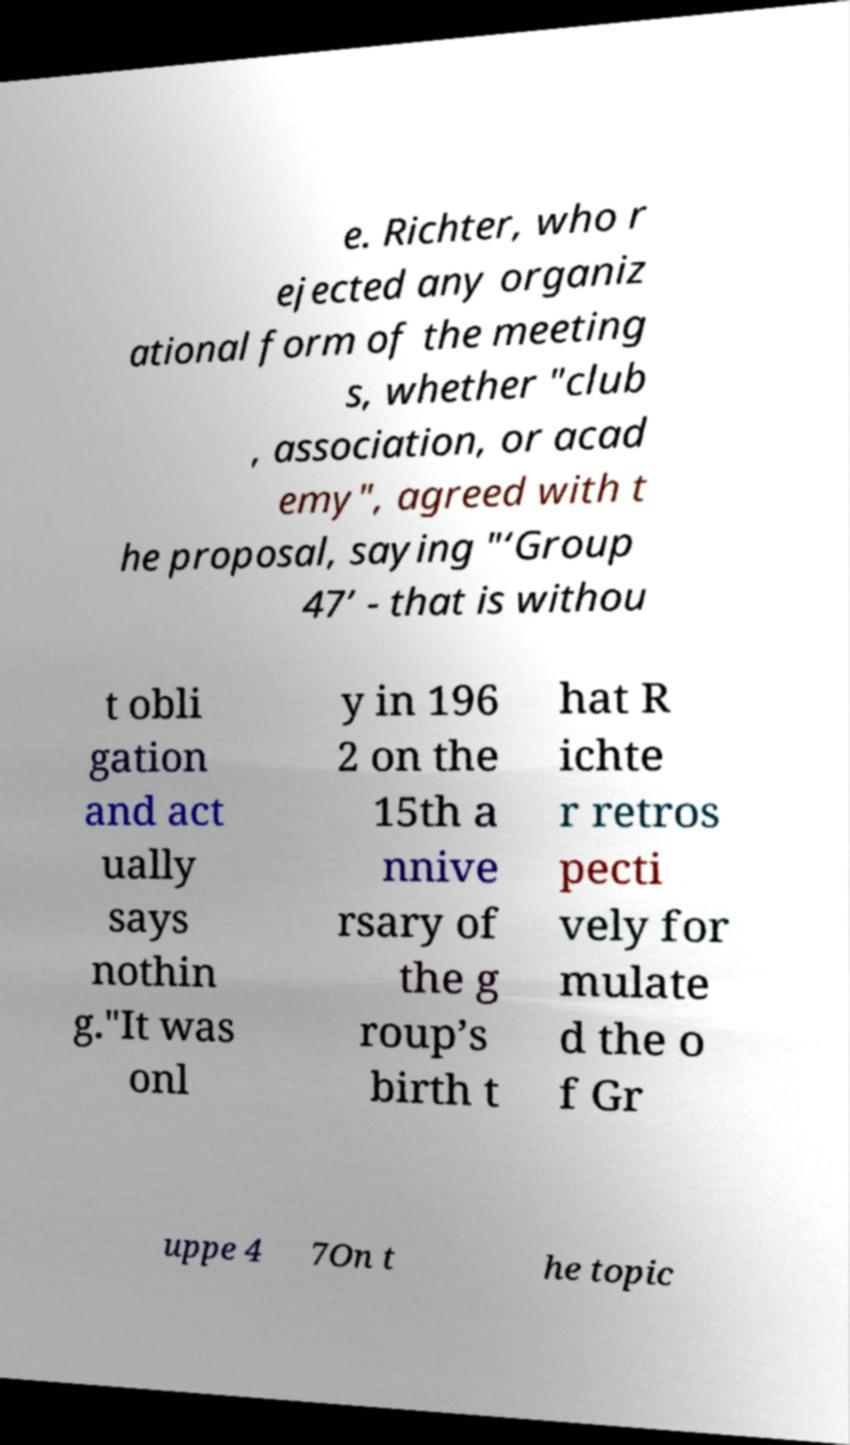Can you read and provide the text displayed in the image?This photo seems to have some interesting text. Can you extract and type it out for me? e. Richter, who r ejected any organiz ational form of the meeting s, whether "club , association, or acad emy", agreed with t he proposal, saying "‘Group 47’ - that is withou t obli gation and act ually says nothin g."It was onl y in 196 2 on the 15th a nnive rsary of the g roup’s birth t hat R ichte r retros pecti vely for mulate d the o f Gr uppe 4 7On t he topic 